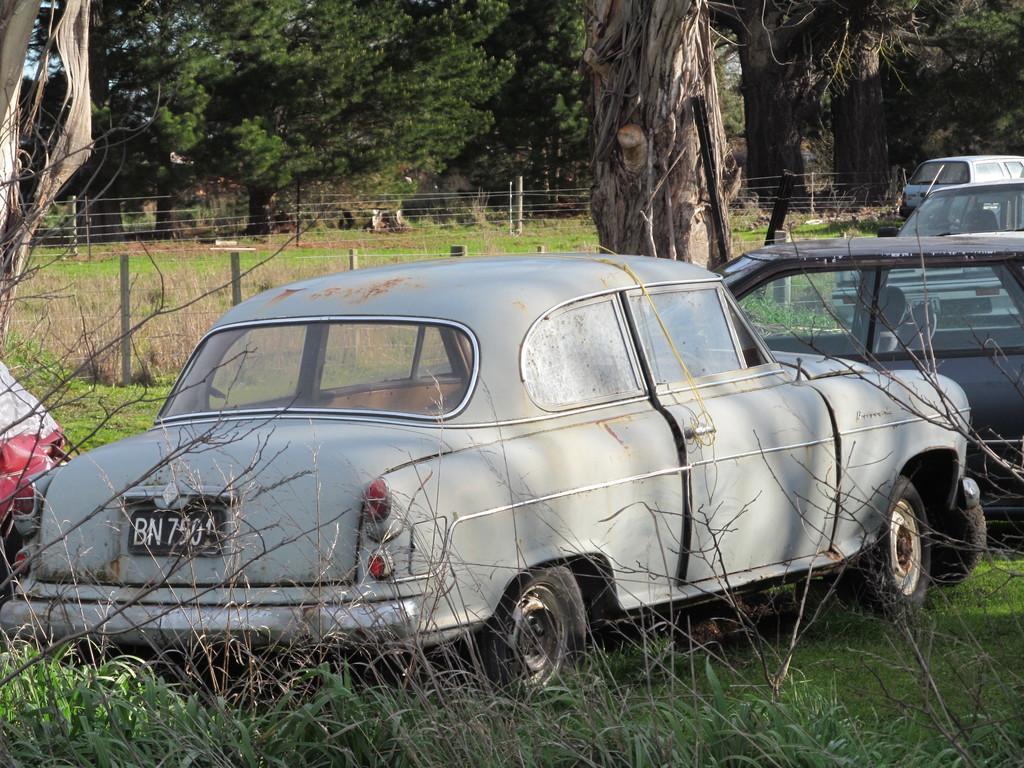Could you give a brief overview of what you see in this image? In this picture I can see vehicles, there is grass, fence, and in the background there are trees. 